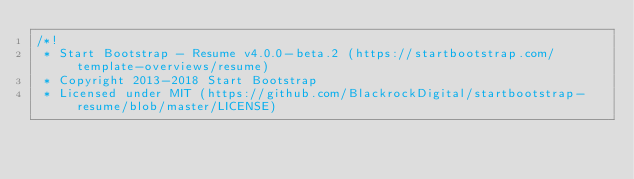Convert code to text. <code><loc_0><loc_0><loc_500><loc_500><_CSS_>/*!
 * Start Bootstrap - Resume v4.0.0-beta.2 (https://startbootstrap.com/template-overviews/resume)
 * Copyright 2013-2018 Start Bootstrap
 * Licensed under MIT (https://github.com/BlackrockDigital/startbootstrap-resume/blob/master/LICENSE)</code> 